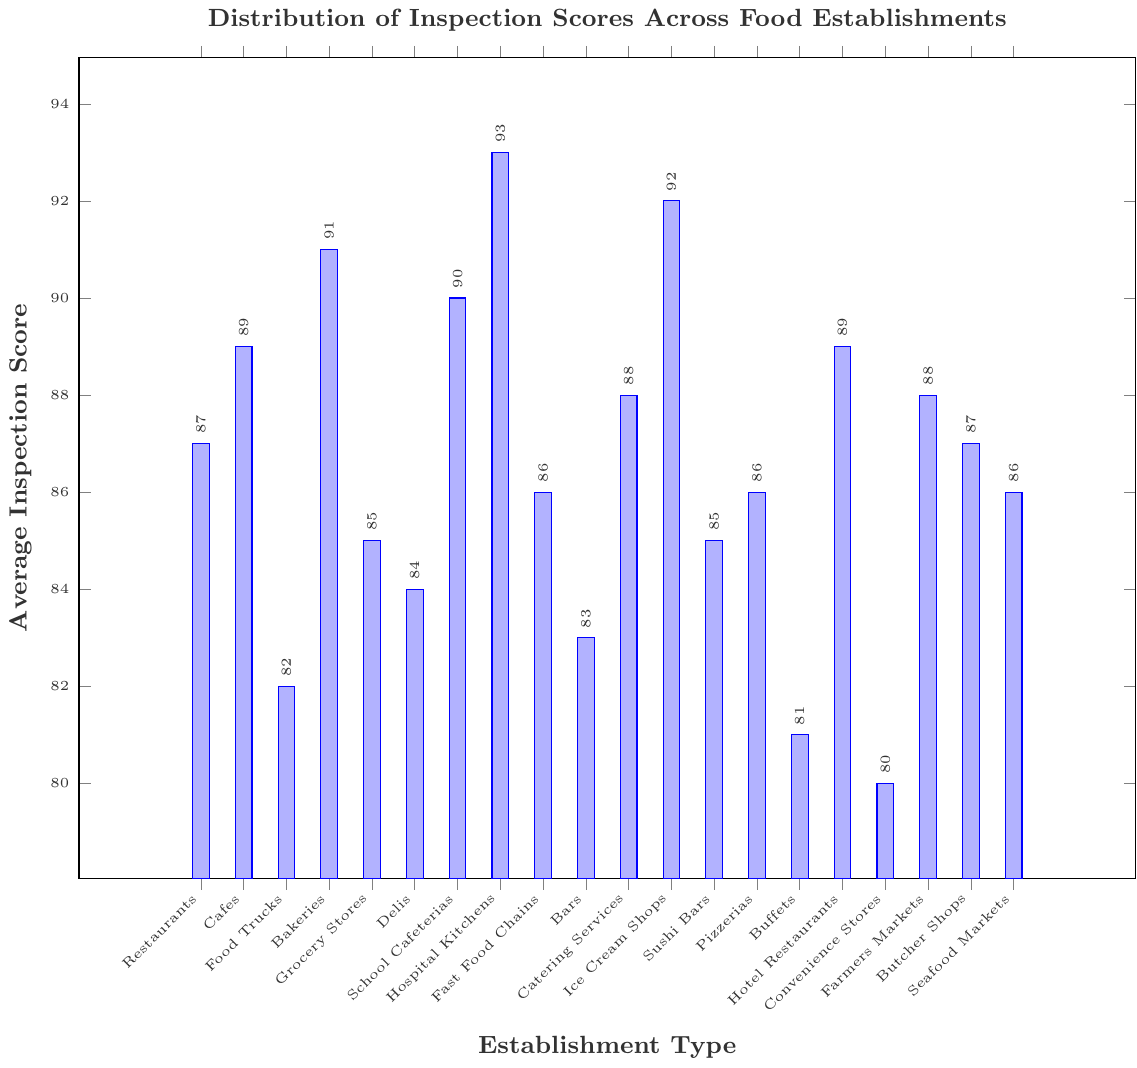what's the highest average inspection score among the food establishments? The highest average inspection score is identified by finding the maximum value in the data set. By inspecting the bars in the chart, the tallest bar corresponds to Hospital Kitchens with an average score of 93.
Answer: Hospital Kitchens which food establishment type has the lowest average inspection score? The lowest average inspection score is identified by finding the minimum value in the data set. The shortest bar corresponds to Convenience Stores with an average score of 80.
Answer: Convenience Stores how much higher is the average inspection score of Bakeries compared to Food Trucks? The average inspection score for Bakeries is 91, and for Food Trucks it is 82. Subtract the score of Food Trucks from Bakeries: 91 - 82 = 9.
Answer: 9 how many types of food establishments have an average inspection score above 90? Count the number of bars that exceed the height corresponding to an average inspection score of 90. Hospital Kitchens, Ice Cream Shops, and Bakeries all have scores above 90.
Answer: 3 is the average inspection score of Restaurants higher than that of Fast Food Chains? The average inspection score for Restaurants is 87, while for Fast Food Chains it is 86. Since 87 is greater than 86, the Restaurants have a higher score.
Answer: Yes what is the combined average inspection score of Bars, Delis, and Grocery Stores? Add the average inspection scores of Bars (83), Delis (84), and Grocery Stores (85): 83 + 84 + 85 = 252.
Answer: 252 which establishment type has an equal average inspection score to the mean of the scores for School Cafeterias and Sushi Bars? First, find the mean of the scores for School Cafeterias (90) and Sushi Bars (85): (90 + 85) / 2 = 87.5. Look for the establishment type with an average inspection score closest to 87.5. Both Seafood Markets and Pizzerias have scores of 86, which is the closest.
Answer: Seafood Markets/Pizzerias how much is the difference in average inspection scores between the highest (Hospital Kitchens) and lowest (Convenience Stores) establishments? The highest score is 93 (Hospital Kitchens) and the lowest score is 80 (Convenience Stores). Subtract the lowest from the highest: 93 - 80 = 13.
Answer: 13 what is the average inspection score for all hospitality-related establishments? For hospitality-related establishments including Restaurants (87), Cafes (89), Bars (83), Catering Services (88), Pizzerias (86), Buffets (81), Hotel Restaurants (89), and Farm Markets (88), sum their scores and divide by the number of establishments: (87 + 89 + 83 + 88 + 86 + 81 + 89 + 88) / 8 = 86.375.
Answer: 86.38 